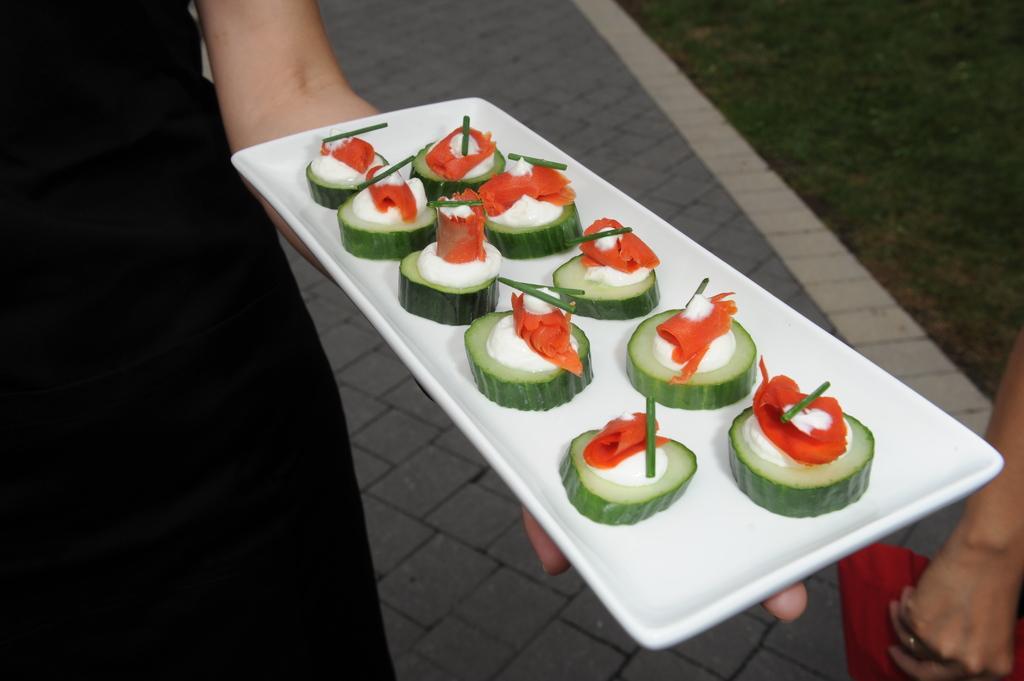Please provide a concise description of this image. In the image we can see two people wearing clothes and the left side person is holding a plate in hand and the plate is in rectangle shape. On the plate we can see food item. 